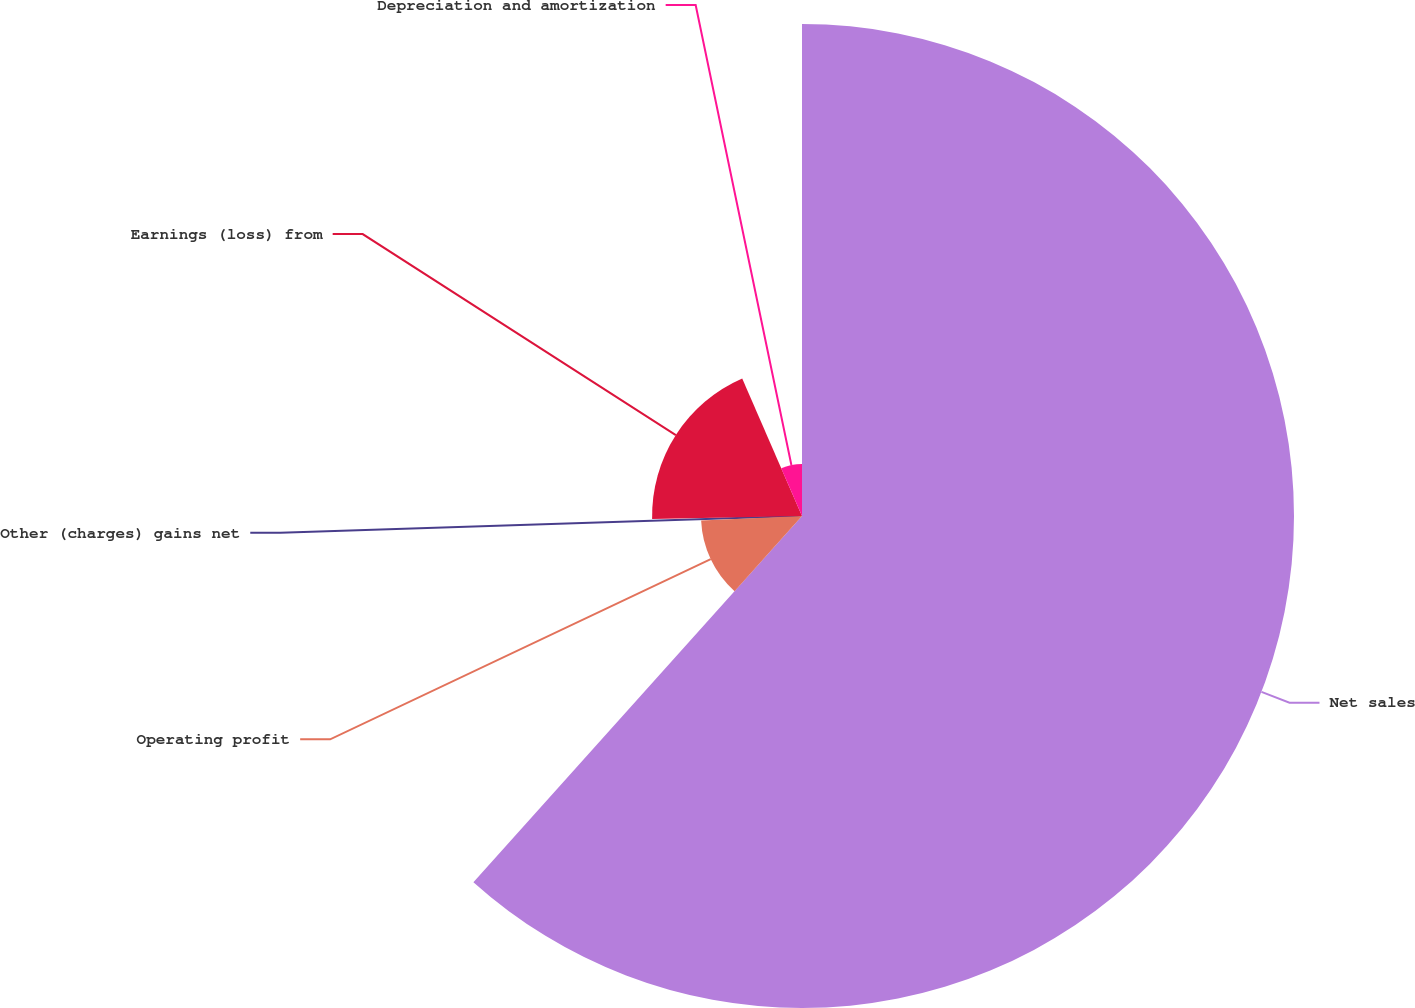<chart> <loc_0><loc_0><loc_500><loc_500><pie_chart><fcel>Net sales<fcel>Operating profit<fcel>Other (charges) gains net<fcel>Earnings (loss) from<fcel>Depreciation and amortization<nl><fcel>61.64%<fcel>12.65%<fcel>0.4%<fcel>18.78%<fcel>6.53%<nl></chart> 